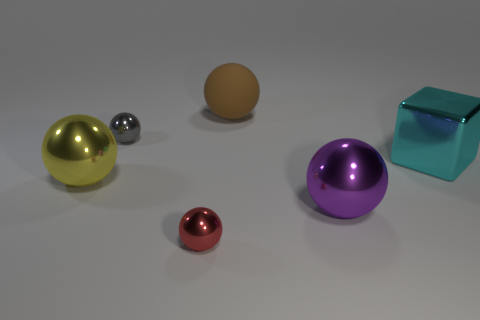There is a cube that is the same size as the yellow sphere; what is its material?
Your answer should be very brief. Metal. How many things are either metallic objects that are to the left of the small gray metallic ball or large balls on the left side of the gray sphere?
Ensure brevity in your answer.  1. Are there any other big brown things of the same shape as the large brown rubber object?
Provide a succinct answer. No. How many rubber objects are gray objects or big yellow things?
Give a very brief answer. 0. There is a large cyan metallic thing; what shape is it?
Keep it short and to the point. Cube. How many cubes have the same material as the yellow sphere?
Offer a terse response. 1. What color is the large cube that is the same material as the large purple thing?
Your answer should be compact. Cyan. There is a metallic ball behind the yellow metallic sphere; is its size the same as the small red sphere?
Offer a very short reply. Yes. What color is the other tiny shiny thing that is the same shape as the tiny red metallic thing?
Offer a very short reply. Gray. What shape is the cyan object that is behind the large metallic thing that is to the left of the large sphere right of the rubber object?
Ensure brevity in your answer.  Cube. 